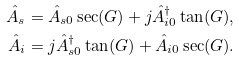Convert formula to latex. <formula><loc_0><loc_0><loc_500><loc_500>\hat { A } _ { s } & = \hat { A } _ { s 0 } \sec ( G ) + j \hat { A } _ { i 0 } ^ { \dagger } \tan ( G ) , \\ \hat { A } _ { i } & = j \hat { A } _ { s 0 } ^ { \dagger } \tan ( G ) + \hat { A } _ { i 0 } \sec ( G ) .</formula> 